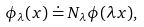Convert formula to latex. <formula><loc_0><loc_0><loc_500><loc_500>\phi _ { \lambda } ( x ) \doteq N _ { \lambda } \phi ( \lambda x ) ,</formula> 